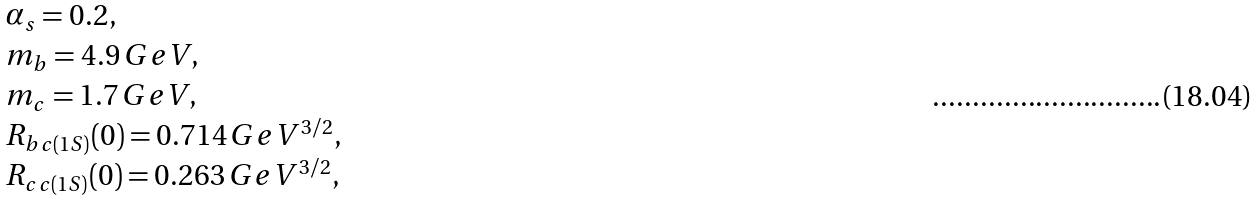<formula> <loc_0><loc_0><loc_500><loc_500>\begin{array} { l } { { \alpha _ { s } = 0 . 2 , } } \\ { { m _ { b } = 4 . 9 \, G e V , } } \\ { { m _ { c } = 1 . 7 \, G e V , } } \\ { { R _ { b c ( 1 S ) } ( 0 ) = 0 . 7 1 4 \, G e V ^ { 3 / 2 } , } } \\ { { R _ { c c ( 1 S ) } ( 0 ) = 0 . 2 6 3 \, G e V ^ { 3 / 2 } , } } \end{array}</formula> 